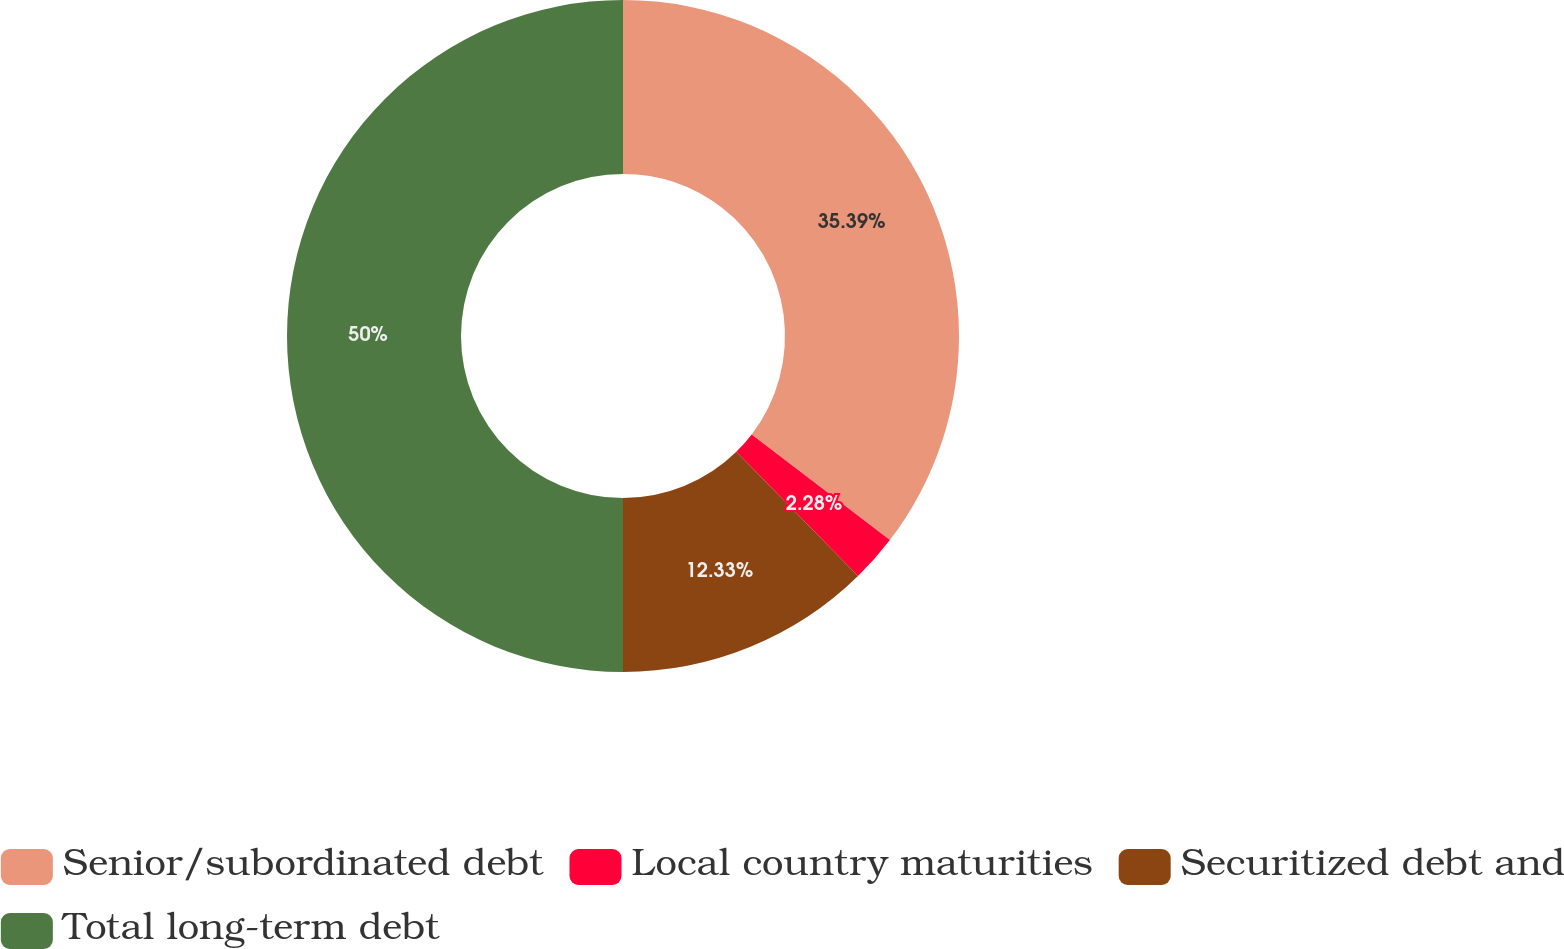<chart> <loc_0><loc_0><loc_500><loc_500><pie_chart><fcel>Senior/subordinated debt<fcel>Local country maturities<fcel>Securitized debt and<fcel>Total long-term debt<nl><fcel>35.39%<fcel>2.28%<fcel>12.33%<fcel>50.0%<nl></chart> 